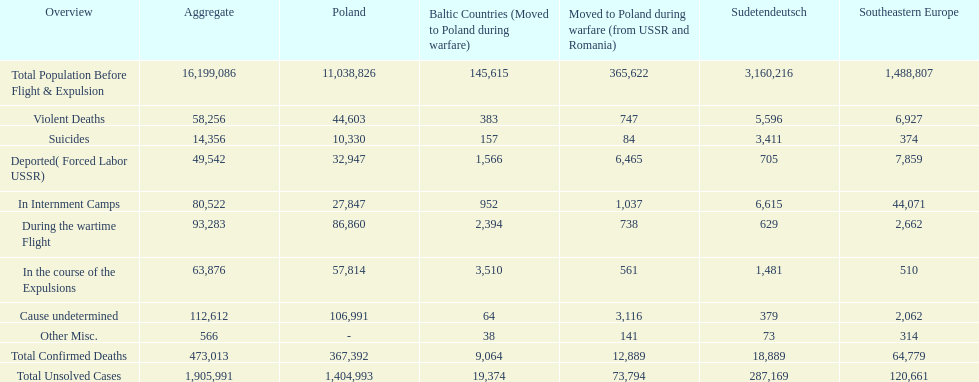Were there more cause undetermined or miscellaneous deaths in the baltic states? Cause undetermined. 